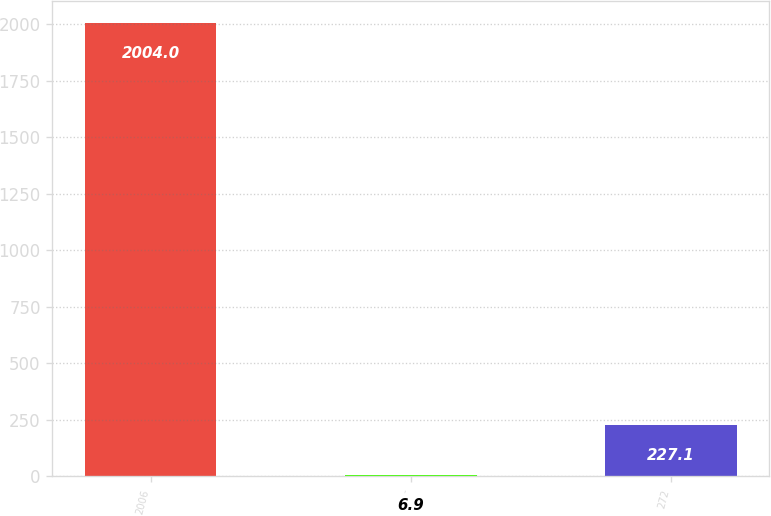<chart> <loc_0><loc_0><loc_500><loc_500><bar_chart><fcel>2006<fcel>-<fcel>272<nl><fcel>2004<fcel>6.9<fcel>227.1<nl></chart> 